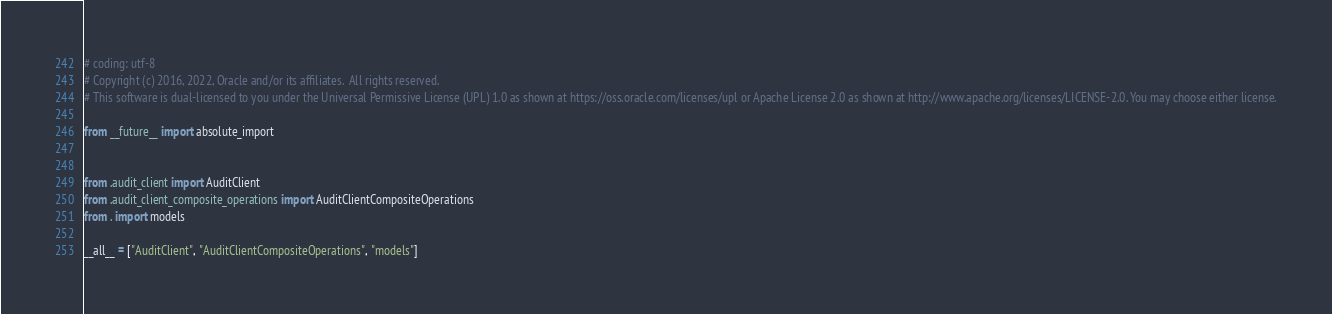Convert code to text. <code><loc_0><loc_0><loc_500><loc_500><_Python_># coding: utf-8
# Copyright (c) 2016, 2022, Oracle and/or its affiliates.  All rights reserved.
# This software is dual-licensed to you under the Universal Permissive License (UPL) 1.0 as shown at https://oss.oracle.com/licenses/upl or Apache License 2.0 as shown at http://www.apache.org/licenses/LICENSE-2.0. You may choose either license.

from __future__ import absolute_import


from .audit_client import AuditClient
from .audit_client_composite_operations import AuditClientCompositeOperations
from . import models

__all__ = ["AuditClient", "AuditClientCompositeOperations", "models"]
</code> 